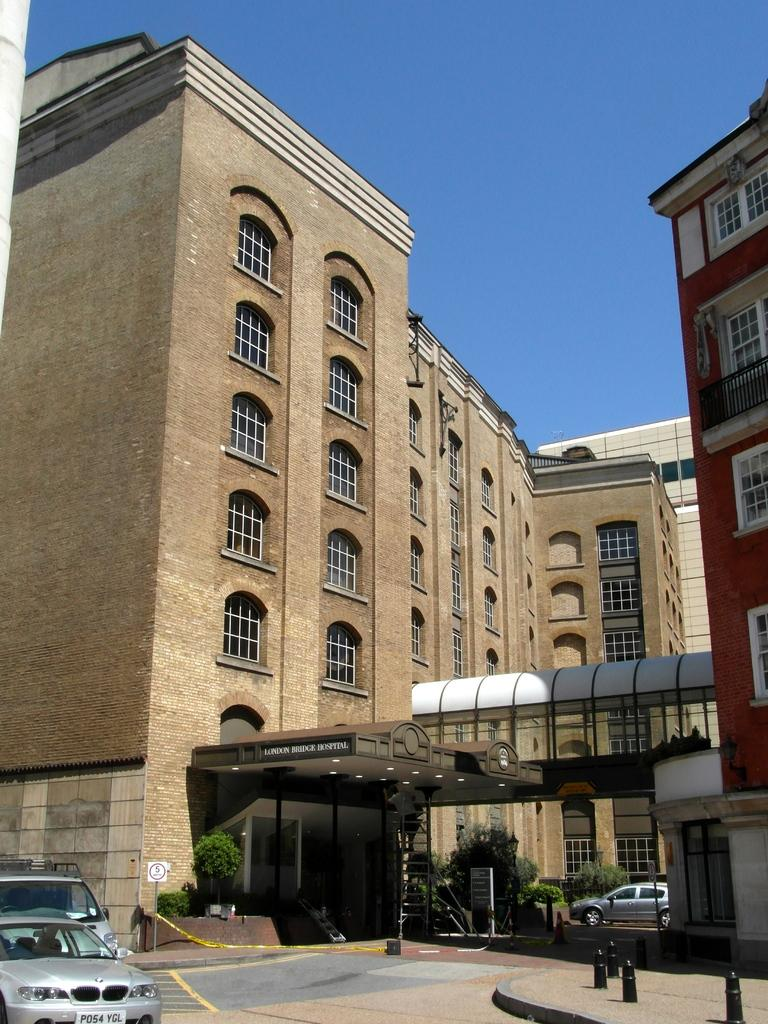What type of structures are visible in the image? There are buildings with windows in the image. Can you describe a specific architectural feature in the image? There is a bridge with an arch in the image. What type of vegetation is present in the image? There are trees in the image. What type of transportation can be seen in the image? There are vehicles in the image. What can be seen in the background of the image? The sky is visible in the background of the image. Where is the bottle placed on the stage in the image? There is no bottle or stage present in the image. What type of star can be seen in the image? There are no stars visible in the image; only buildings, a bridge, trees, vehicles, and the sky are present. 